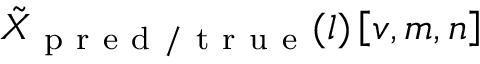<formula> <loc_0><loc_0><loc_500><loc_500>\tilde { X } _ { p r e d / t r u e } ( l ) \left [ v , m , n \right ]</formula> 